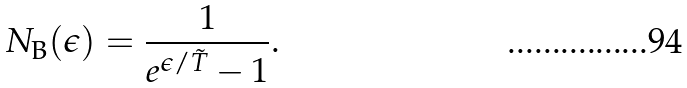<formula> <loc_0><loc_0><loc_500><loc_500>N _ { \text {B} } ( \epsilon ) = \frac { 1 } { e ^ { \epsilon / \tilde { T } } - 1 } .</formula> 